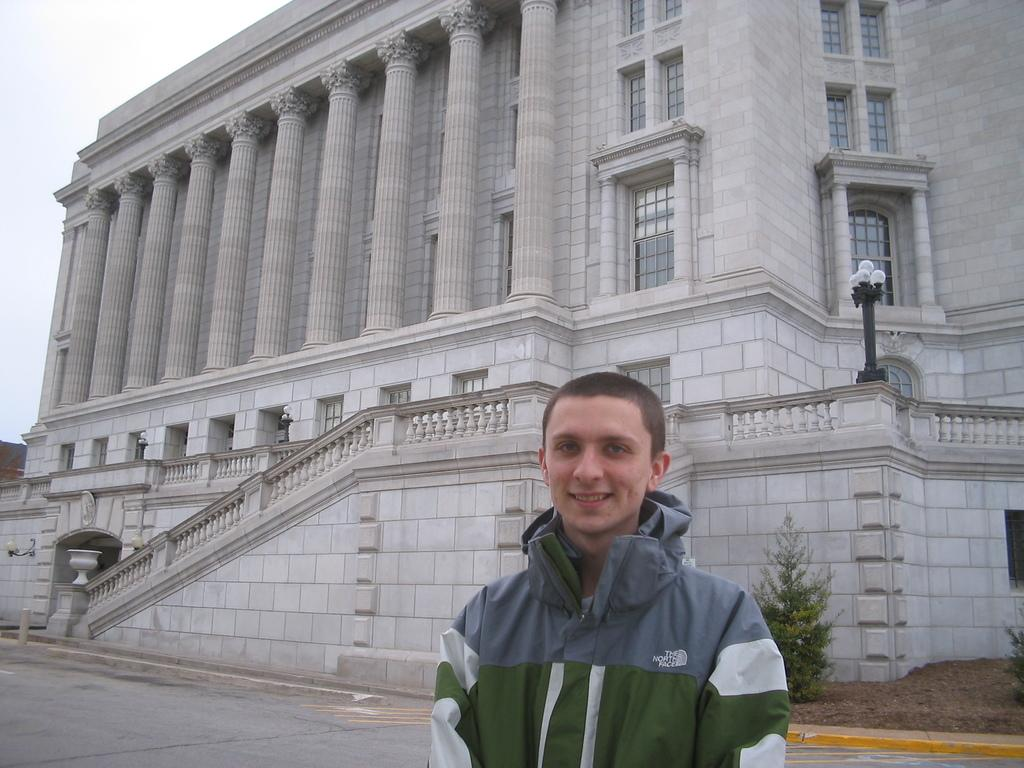<image>
Offer a succinct explanation of the picture presented. A man in a The North Face jacket stands in front of a city building. 